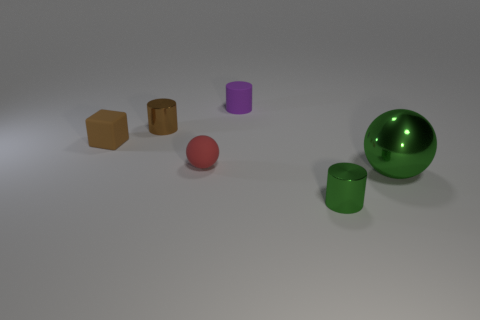Is there any other thing that has the same size as the metal sphere?
Your answer should be very brief. No. Is there any other thing that is the same shape as the brown rubber thing?
Your answer should be very brief. No. There is a metallic object that is behind the small green cylinder and to the right of the tiny purple matte cylinder; what shape is it?
Offer a very short reply. Sphere. Are the thing to the right of the small green shiny cylinder and the small green thing made of the same material?
Ensure brevity in your answer.  Yes. How many things are either brown rubber cubes or cylinders that are in front of the small purple matte cylinder?
Give a very brief answer. 3. There is a tiny cube that is made of the same material as the tiny red ball; what is its color?
Offer a terse response. Brown. How many tiny cyan objects are made of the same material as the big ball?
Provide a succinct answer. 0. How many red metallic spheres are there?
Your response must be concise. 0. Does the shiny cylinder that is right of the tiny brown metallic cylinder have the same color as the big metal thing to the right of the brown matte object?
Provide a short and direct response. Yes. How many large green things are behind the red matte object?
Your answer should be very brief. 0. 